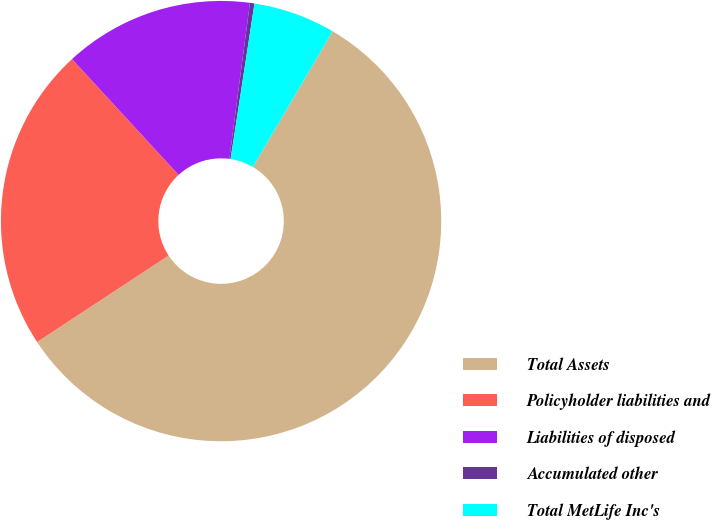Convert chart. <chart><loc_0><loc_0><loc_500><loc_500><pie_chart><fcel>Total Assets<fcel>Policyholder liabilities and<fcel>Liabilities of disposed<fcel>Accumulated other<fcel>Total MetLife Inc's<nl><fcel>57.29%<fcel>22.42%<fcel>13.93%<fcel>0.33%<fcel>6.03%<nl></chart> 